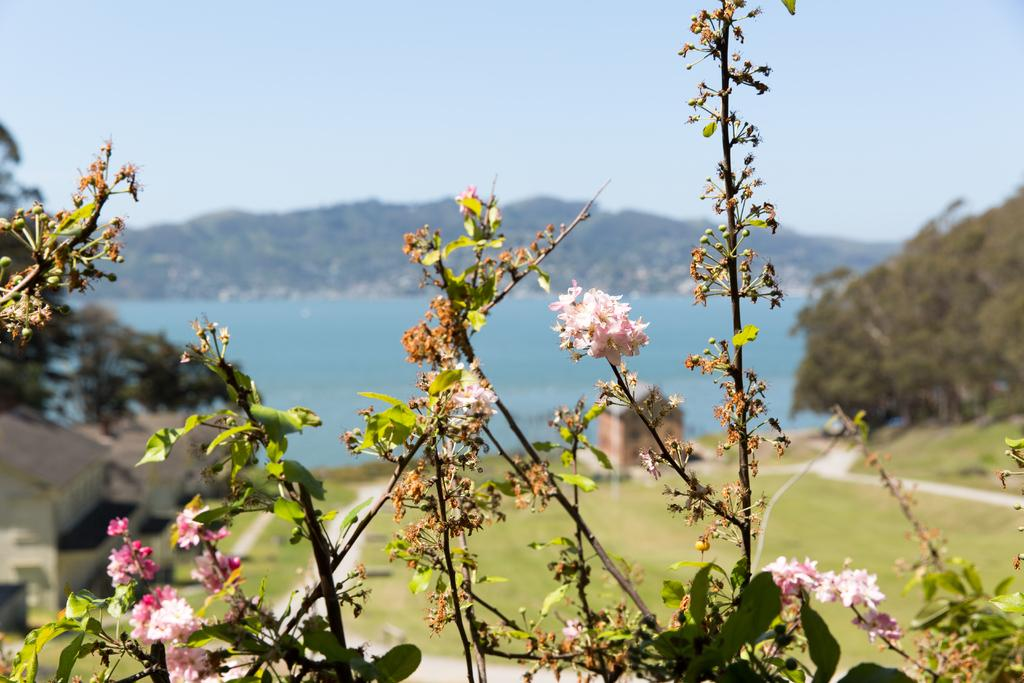What type of plants can be seen in the image? There are flowers, stems, and leaves visible in the image. Can you describe the background of the image? The background of the image is blurred and includes trees, grass, walkways, houses, water, a hill, and the sky. What type of animals can be seen at the zoo in the image? There is no zoo present in the image; it features flowers, stems, leaves, and a blurred background with various elements. 